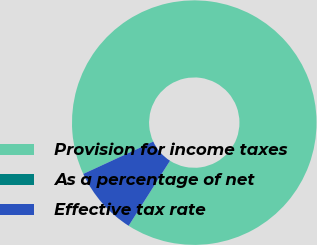Convert chart. <chart><loc_0><loc_0><loc_500><loc_500><pie_chart><fcel>Provision for income taxes<fcel>As a percentage of net<fcel>Effective tax rate<nl><fcel>90.91%<fcel>0.0%<fcel>9.09%<nl></chart> 